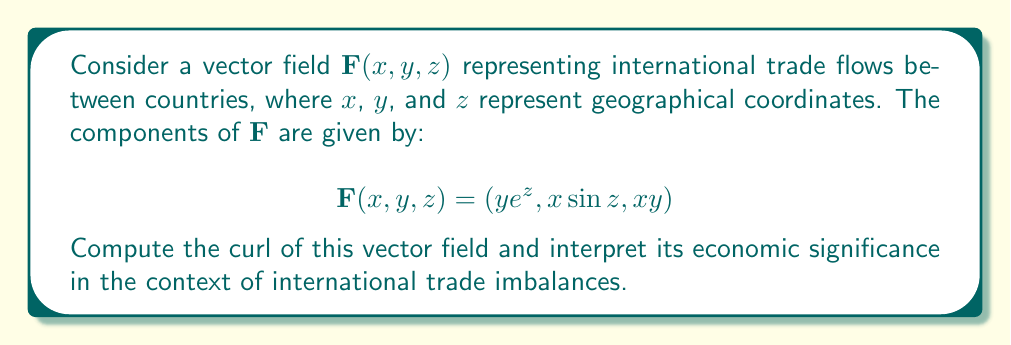Provide a solution to this math problem. To compute the curl of the vector field $\mathbf{F}(x, y, z)$, we need to use the curl operator in 3D space:

$$\text{curl } \mathbf{F} = \nabla \times \mathbf{F} = \left(\frac{\partial F_z}{\partial y} - \frac{\partial F_y}{\partial z}\right)\mathbf{i} + \left(\frac{\partial F_x}{\partial z} - \frac{\partial F_z}{\partial x}\right)\mathbf{j} + \left(\frac{\partial F_y}{\partial x} - \frac{\partial F_x}{\partial y}\right)\mathbf{k}$$

Let's calculate each component:

1. $\frac{\partial F_z}{\partial y} - \frac{\partial F_y}{\partial z}$:
   $\frac{\partial F_z}{\partial y} = \frac{\partial}{\partial y}(xy) = x$
   $\frac{\partial F_y}{\partial z} = \frac{\partial}{\partial z}(x\sin z) = x\cos z$
   $\frac{\partial F_z}{\partial y} - \frac{\partial F_y}{\partial z} = x - x\cos z = x(1 - \cos z)$

2. $\frac{\partial F_x}{\partial z} - \frac{\partial F_z}{\partial x}$:
   $\frac{\partial F_x}{\partial z} = \frac{\partial}{\partial z}(ye^z) = ye^z$
   $\frac{\partial F_z}{\partial x} = \frac{\partial}{\partial x}(xy) = y$
   $\frac{\partial F_x}{\partial z} - \frac{\partial F_z}{\partial x} = ye^z - y = y(e^z - 1)$

3. $\frac{\partial F_y}{\partial x} - \frac{\partial F_x}{\partial y}$:
   $\frac{\partial F_y}{\partial x} = \frac{\partial}{\partial x}(x\sin z) = \sin z$
   $\frac{\partial F_x}{\partial y} = \frac{\partial}{\partial y}(ye^z) = e^z$
   $\frac{\partial F_y}{\partial x} - \frac{\partial F_x}{\partial y} = \sin z - e^z$

Therefore, the curl of $\mathbf{F}$ is:

$$\text{curl } \mathbf{F} = x(1 - \cos z)\mathbf{i} + y(e^z - 1)\mathbf{j} + (\sin z - e^z)\mathbf{k}$$

Interpreting the economic significance:

1. The $x(1 - \cos z)$ component represents trade imbalances in the east-west direction, varying with latitude.
2. The $y(e^z - 1)$ component indicates north-south trade imbalances, exponentially increasing with altitude.
3. The $(\sin z - e^z)$ component shows vertical trade imbalances, which could represent differences in trade between countries at different economic development levels.

The non-zero curl indicates that the trade flows are not conservative, suggesting the presence of trade imbalances and potential for economic inefficiencies or opportunities in the global market.
Answer: $$\text{curl } \mathbf{F} = x(1 - \cos z)\mathbf{i} + y(e^z - 1)\mathbf{j} + (\sin z - e^z)\mathbf{k}$$ 